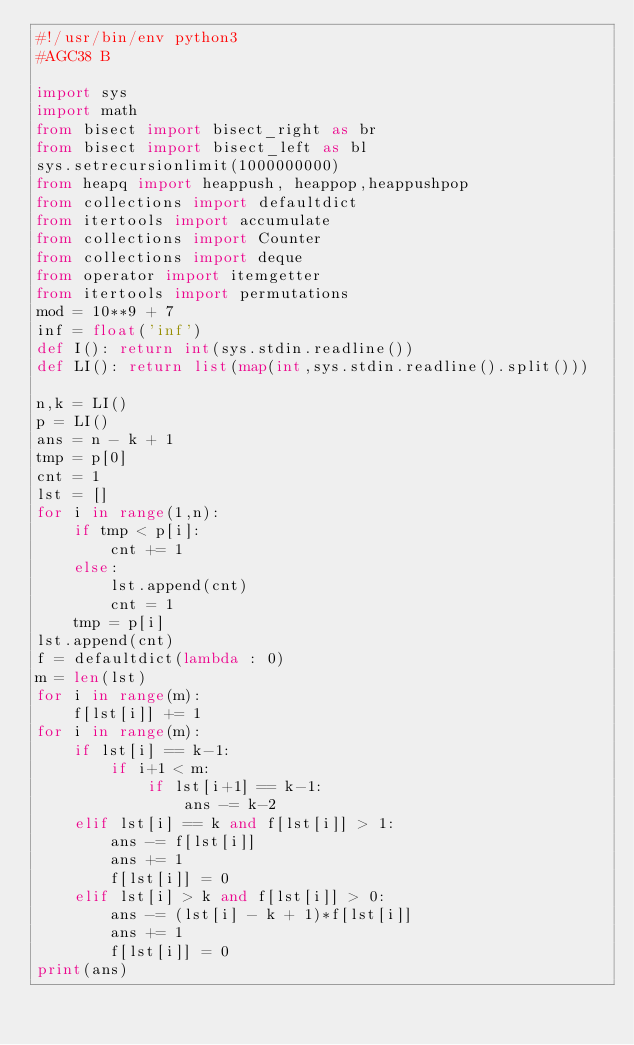<code> <loc_0><loc_0><loc_500><loc_500><_Python_>#!/usr/bin/env python3
#AGC38 B

import sys
import math
from bisect import bisect_right as br
from bisect import bisect_left as bl
sys.setrecursionlimit(1000000000)
from heapq import heappush, heappop,heappushpop
from collections import defaultdict
from itertools import accumulate
from collections import Counter
from collections import deque
from operator import itemgetter
from itertools import permutations
mod = 10**9 + 7
inf = float('inf')
def I(): return int(sys.stdin.readline())
def LI(): return list(map(int,sys.stdin.readline().split()))

n,k = LI()
p = LI()
ans = n - k + 1
tmp = p[0]
cnt = 1
lst = []
for i in range(1,n):
    if tmp < p[i]:
        cnt += 1
    else:
        lst.append(cnt)
        cnt = 1
    tmp = p[i]
lst.append(cnt)
f = defaultdict(lambda : 0)
m = len(lst)
for i in range(m):
    f[lst[i]] += 1
for i in range(m):
    if lst[i] == k-1:
        if i+1 < m:
            if lst[i+1] == k-1:
                ans -= k-2
    elif lst[i] == k and f[lst[i]] > 1:
        ans -= f[lst[i]]
        ans += 1
        f[lst[i]] = 0
    elif lst[i] > k and f[lst[i]] > 0:
        ans -= (lst[i] - k + 1)*f[lst[i]]
        ans += 1
        f[lst[i]] = 0
print(ans)</code> 